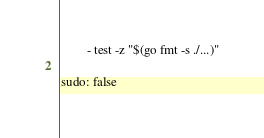Convert code to text. <code><loc_0><loc_0><loc_500><loc_500><_YAML_>        - test -z "$(go fmt -s ./...)"

sudo: false
</code> 